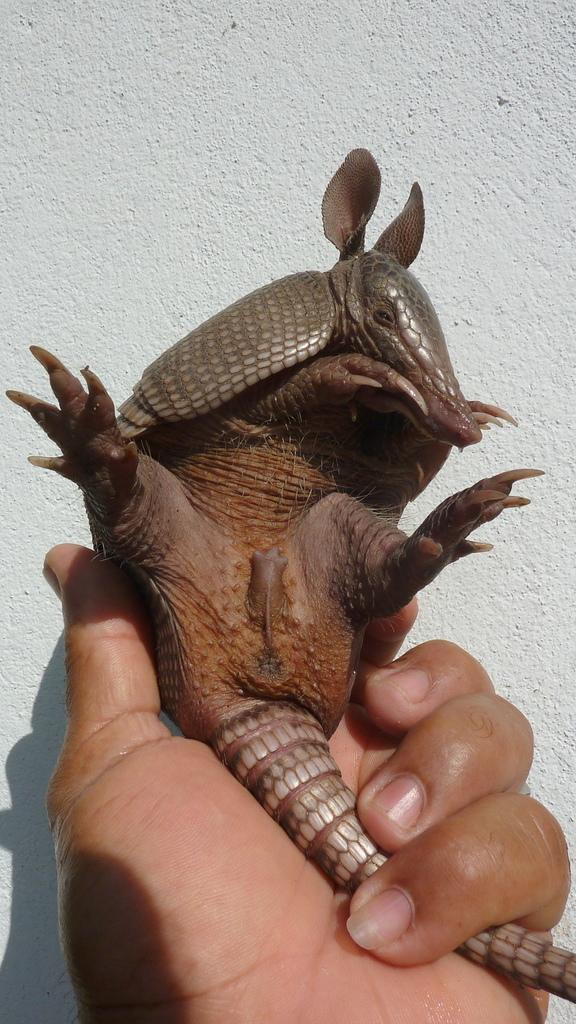What is the person holding in their hand at the bottom of the image? The person is holding an armadillo in their hand at the bottom of the image. What can be seen in the background of the image? There is a wall in the background of the image. What type of brush is being used to paint the respect on the wall in the image? There is no brush or painting of respect present in the image; it only features a person holding an armadillo and a wall in the background. 